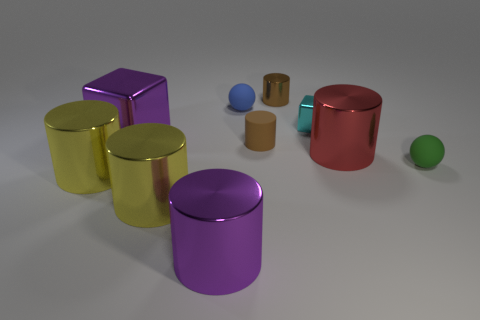Do the tiny cube and the small ball behind the red shiny cylinder have the same color?
Give a very brief answer. No. What is the size of the brown cylinder that is the same material as the small blue thing?
Your answer should be very brief. Small. Is there a metal cylinder that has the same color as the big metal cube?
Make the answer very short. Yes. What number of objects are either spheres that are in front of the small cube or red things?
Your response must be concise. 2. Does the purple cylinder have the same material as the brown cylinder that is on the right side of the matte cylinder?
Ensure brevity in your answer.  Yes. The object that is the same color as the large block is what size?
Offer a very short reply. Large. Are there any tiny things made of the same material as the blue sphere?
Your response must be concise. Yes. How many things are either shiny cylinders to the left of the large red metal thing or tiny objects that are on the left side of the green matte sphere?
Your answer should be compact. 7. There is a small cyan shiny thing; is its shape the same as the small brown thing behind the blue ball?
Offer a terse response. No. How many other objects are there of the same shape as the large red metallic thing?
Your answer should be compact. 5. 